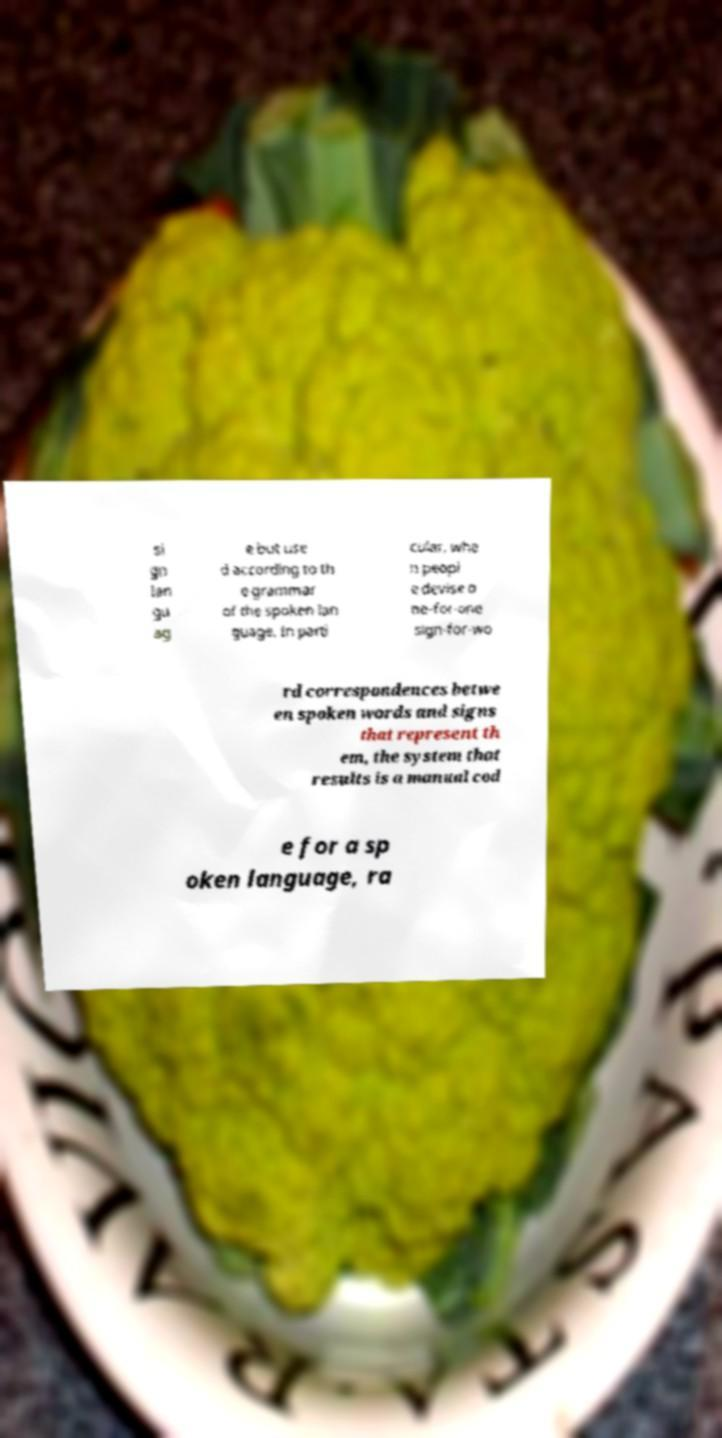Can you read and provide the text displayed in the image?This photo seems to have some interesting text. Can you extract and type it out for me? si gn lan gu ag e but use d according to th e grammar of the spoken lan guage. In parti cular, whe n peopl e devise o ne-for-one sign-for-wo rd correspondences betwe en spoken words and signs that represent th em, the system that results is a manual cod e for a sp oken language, ra 